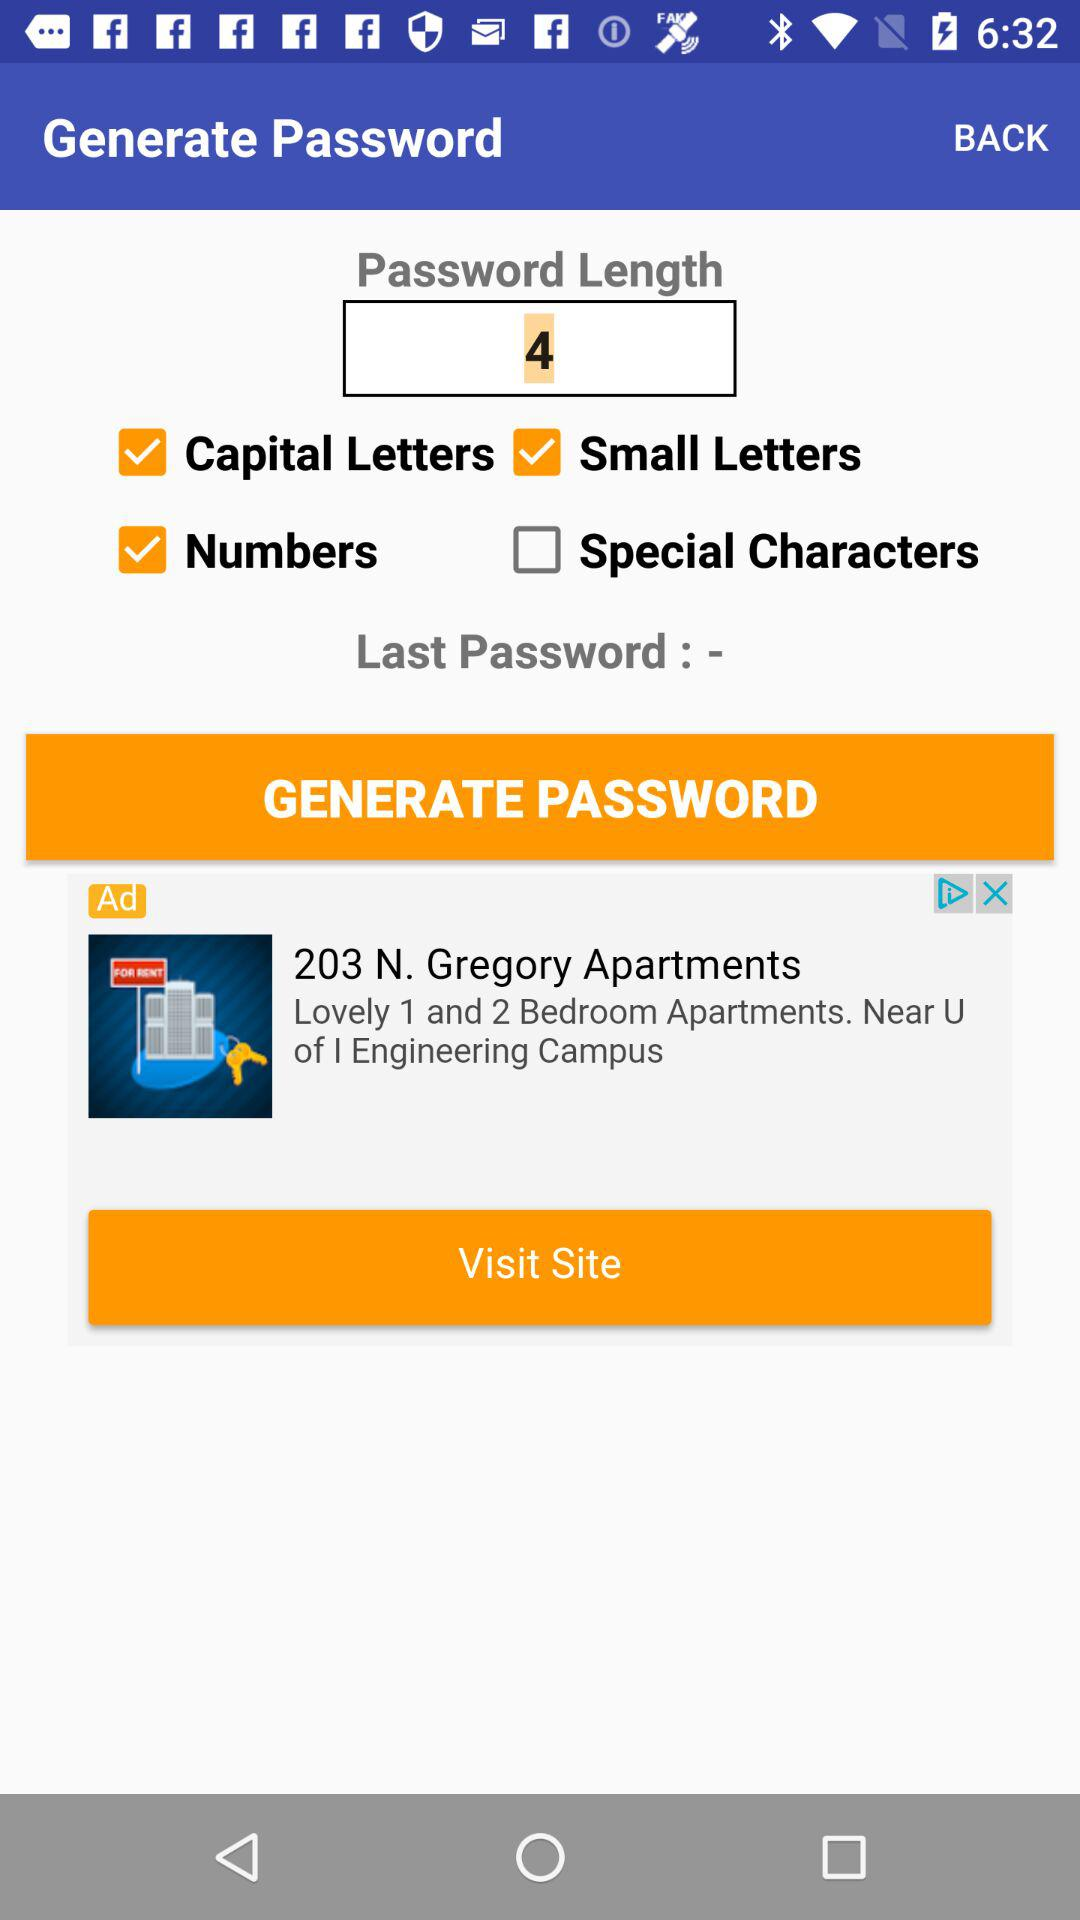What is the selected length of a password? The selected length of a password is 4. 